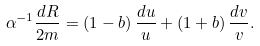<formula> <loc_0><loc_0><loc_500><loc_500>\alpha ^ { - 1 } \frac { d R } { 2 m } = ( 1 - b ) \, \frac { d u } { u } + ( 1 + b ) \, \frac { d v } { v } .</formula> 